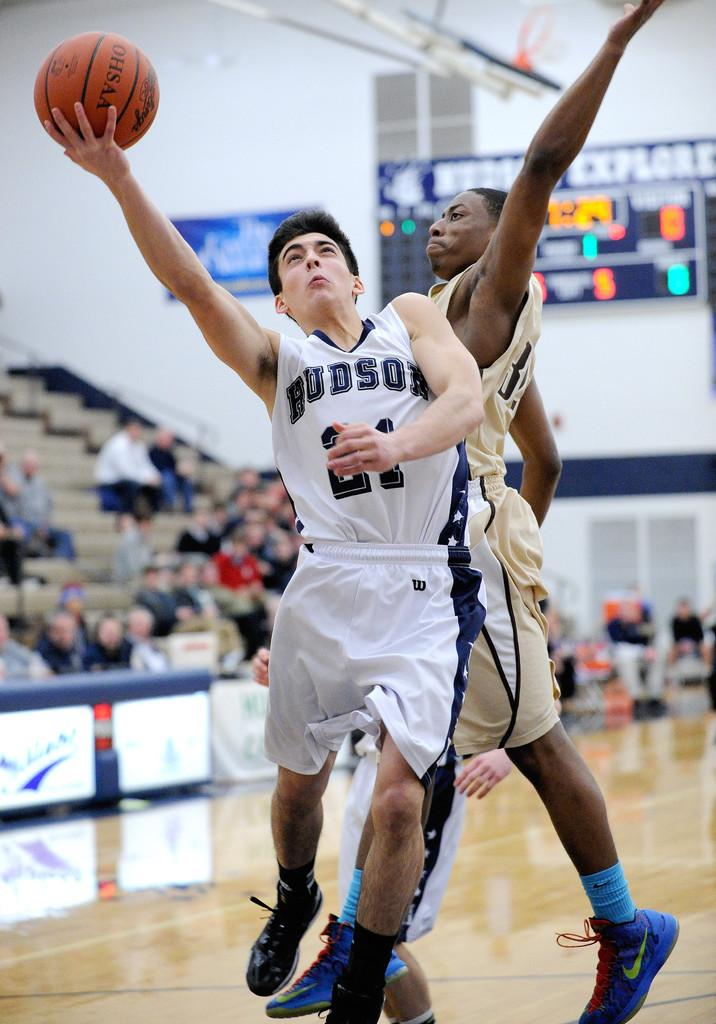What are the two persons in the image doing? The two persons in the image are playing basketball. Where are some other people located in the image? There are some persons sitting on steps on the left side of the image. What type of key is being used to unlock the basketball in the image? There is no key present in the image, and basketballs do not require keys to be unlocked. 